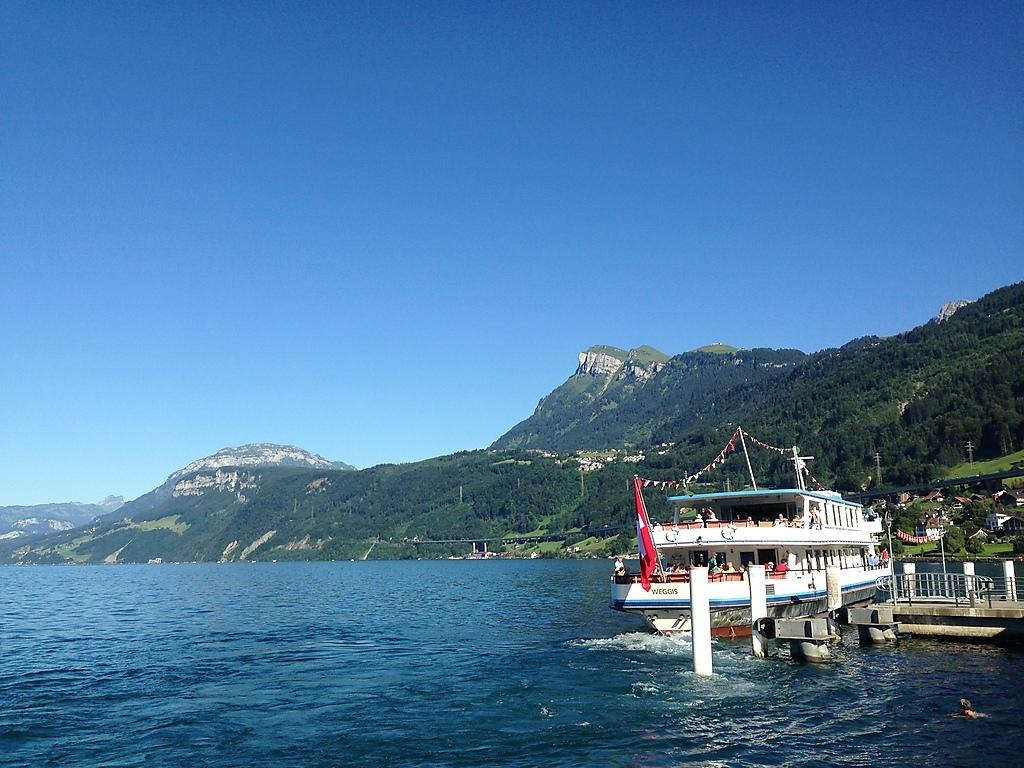What is the main subject of the image? There is a ship floating on the water in the image. Where is the ship located in the image? The ship is on the right side of the image. What type of water body is present in the image? There is a river in the image. What can be seen in the background of the image? There are hills and the sky visible in the background of the image. What type of oatmeal is being served on the ship in the image? There is no oatmeal present in the image; it features a ship floating on a river with hills and the sky visible in the background. Can you tell me the title of the book that is being read on the ship in the image? There is no book present in the image; it only shows a ship floating on a river with hills and the sky visible in the background. 